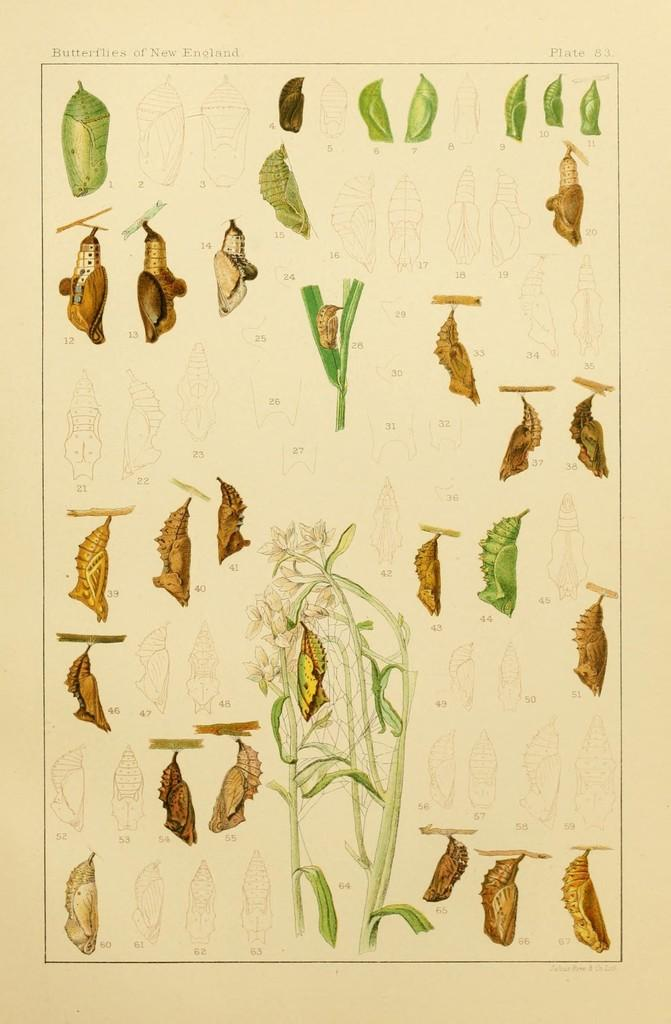What type of drawings are present in the image? There are drawings of cocoons and plants in the image. Can you describe the drawings of cocoons? The drawings of cocoons are depicted in the image. What other type of drawings can be seen in the image? There are also drawings of plants in the image. What type of shock can be seen in the image? There is no shock present in the image; it only contains drawings of cocoons and plants. How many pigs are depicted in the image? There are no pigs present in the image; it only contains drawings of cocoons and plants. 